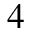<formula> <loc_0><loc_0><loc_500><loc_500>4</formula> 